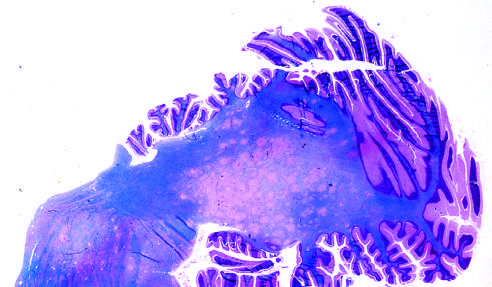what become confluent in places?
Answer the question using a single word or phrase. Areas of demyelination 